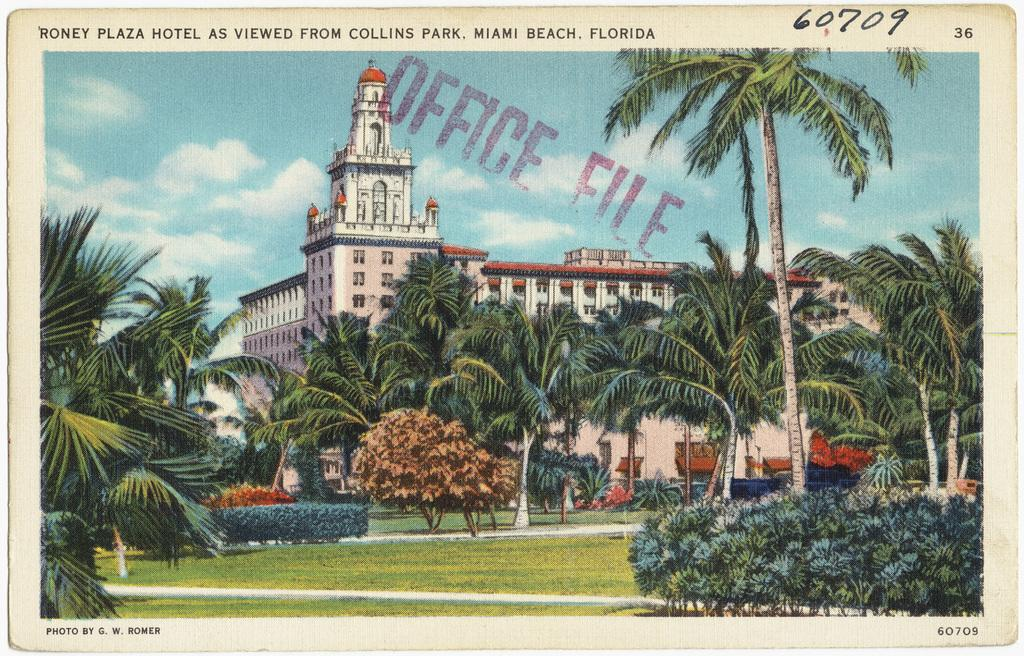What type of vegetation can be seen in the image? There is grass, plants, and trees in the image. What else is present in the image besides vegetation? There is text, buildings, poles, and the sky visible in the image. Can you describe the buildings in the image? The buildings in the image are not described in detail, but their presence is noted. What is visible in the sky in the image? The sky is visible in the image, but no specific details about the sky are provided. What type of impulse can be seen affecting the trees in the image? There is no impulse affecting the trees in the image; they are stationary. What kind of hook is attached to the poles in the image? There is no hook present on the poles in the image. 